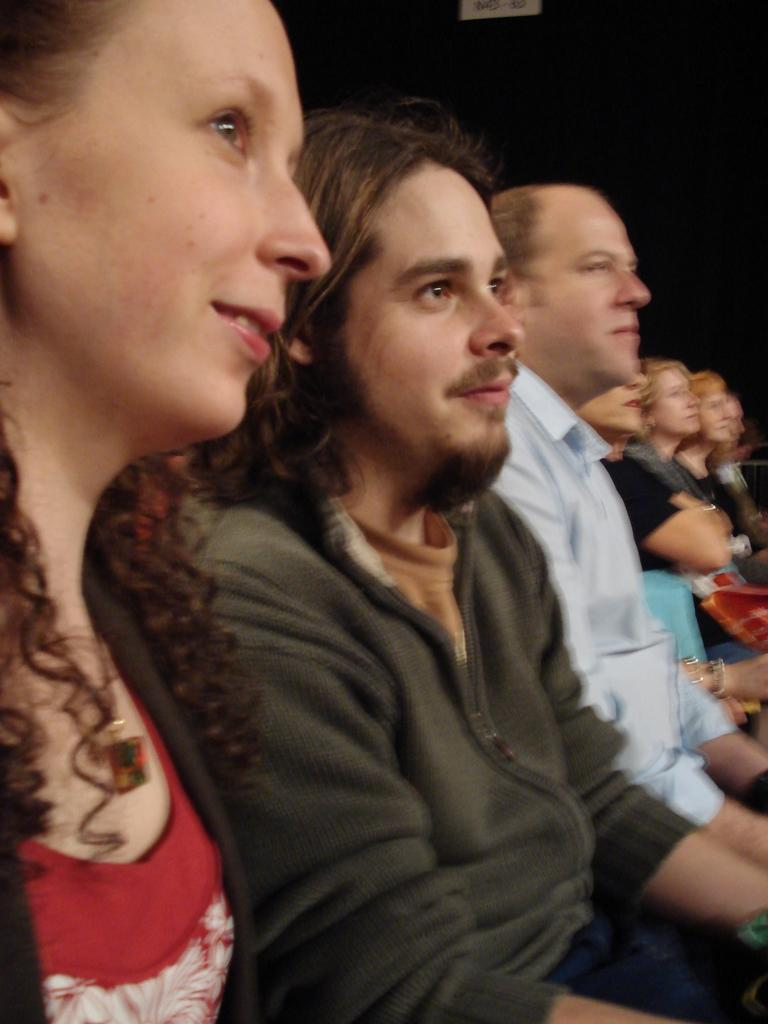How many people are in the image? There are few persons in the image. What is the woman wearing in the image? A woman is wearing a red dress in the image. What is the man wearing in the image? A man is wearing a green jacket in the image. What can be said about the background of the image? The background of the image is dark. What type of vacation is the woman planning based on her outfit in the image? There is no indication of a vacation or any planning in the image, and the woman's outfit does not suggest any specific type of vacation. 